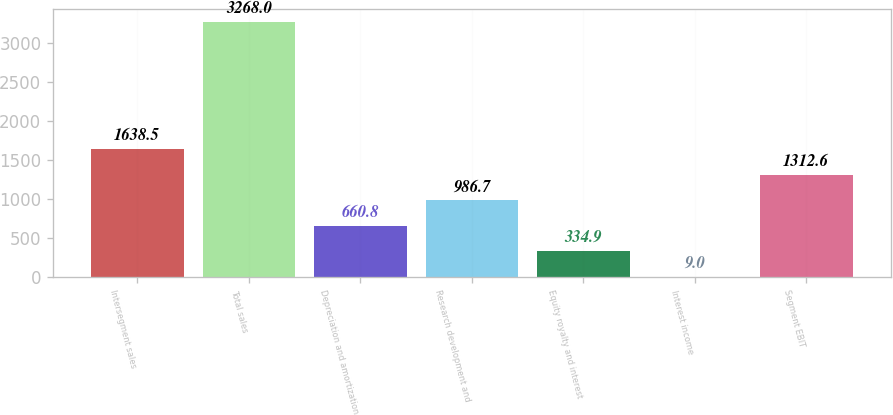Convert chart. <chart><loc_0><loc_0><loc_500><loc_500><bar_chart><fcel>Intersegment sales<fcel>Total sales<fcel>Depreciation and amortization<fcel>Research development and<fcel>Equity royalty and interest<fcel>Interest income<fcel>Segment EBIT<nl><fcel>1638.5<fcel>3268<fcel>660.8<fcel>986.7<fcel>334.9<fcel>9<fcel>1312.6<nl></chart> 